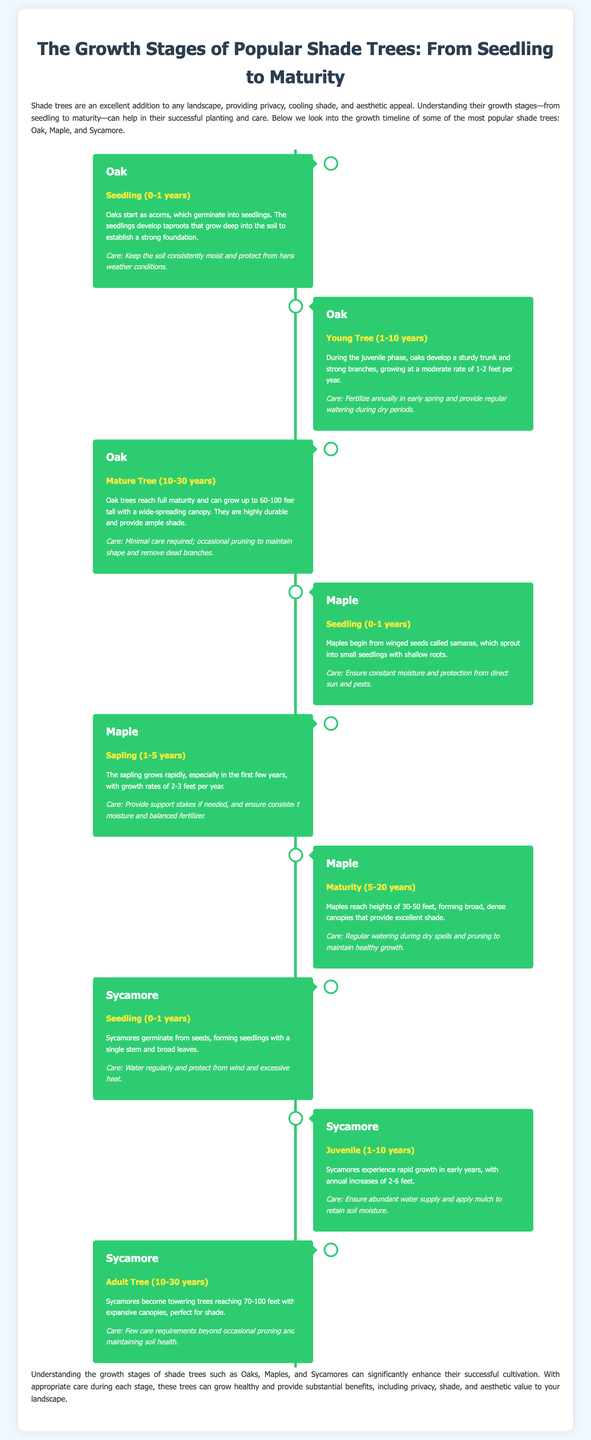What is the first stage of Oak tree growth? The first stage of Oak tree growth is described as "Seedling (0-1 years)" where oaks start as acorns and develop taproots.
Answer: Seedling (0-1 years) How tall can Oak trees grow when mature? The document states that Oak trees can reach heights between 60-100 feet during the maturity stage.
Answer: 60-100 feet What is the average growth rate of a young Oak tree? The growth rate for young Oak trees is indicated as 1-2 feet per year during the juvenile phase.
Answer: 1-2 feet per year Which type of tree has a growth phase labeled "Sapling (1-5 years)"? The Maple tree has a growth phase labeled "Sapling (1-5 years)" where it grows rapidly.
Answer: Maple What care is recommended for a Sycamore tree during the juvenile stage? The document recommends ensuring an abundant water supply and applying mulch to retain soil moisture for Sycamore trees.
Answer: Ensure abundant water supply and apply mulch At what age do Maples reach maturity? Maples are stated to reach maturity between 5-20 years of age in the timeline infographic.
Answer: 5-20 years What type of infographic is this document? The document is a timeline infographic that illustrates growth stages of shade trees from seedlings to maturity.
Answer: Timeline infographic How many types of trees are discussed in the document? The document discusses three types of trees: Oak, Maple, and Sycamore.
Answer: Three What care should be given to Oak trees when they are mature? For mature Oak trees, minimal care is required, specifically occasional pruning to maintain shape.
Answer: Minimal care required; occasional pruning 